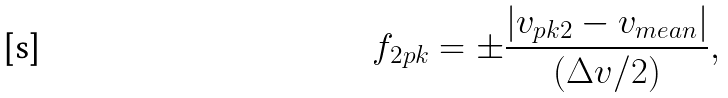Convert formula to latex. <formula><loc_0><loc_0><loc_500><loc_500>f _ { 2 p k } = \pm \frac { | v _ { p k 2 } - v _ { m e a n } | } { ( \Delta v / 2 ) } ,</formula> 